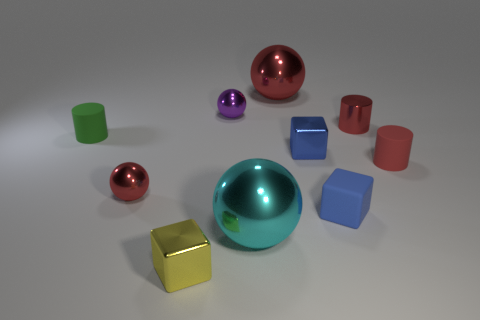Subtract all gray cylinders. How many blue cubes are left? 2 Subtract all rubber cylinders. How many cylinders are left? 1 Subtract all purple balls. How many balls are left? 3 Subtract all cylinders. How many objects are left? 7 Subtract 2 cubes. How many cubes are left? 1 Subtract all tiny shiny spheres. Subtract all red matte cylinders. How many objects are left? 7 Add 2 yellow shiny things. How many yellow shiny things are left? 3 Add 4 tiny matte objects. How many tiny matte objects exist? 7 Subtract 2 red cylinders. How many objects are left? 8 Subtract all cyan cylinders. Subtract all yellow cubes. How many cylinders are left? 3 